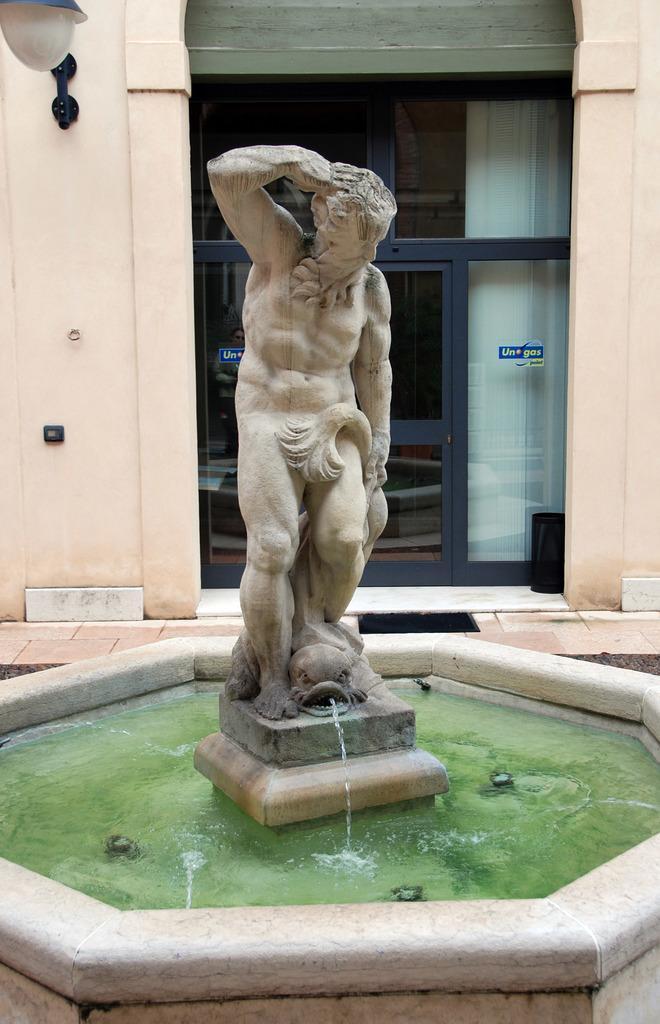Describe this image in one or two sentences. In this image there is sculpture. There is water. There is a wall and a glass door. We can see light. 